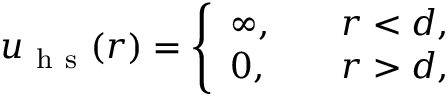Convert formula to latex. <formula><loc_0><loc_0><loc_500><loc_500>\begin{array} { r } { u _ { h s } ( r ) = \left \{ \begin{array} { l l } { \infty , \quad } & { r < d , } \\ { 0 , } & { r > d , } \end{array} } \end{array}</formula> 